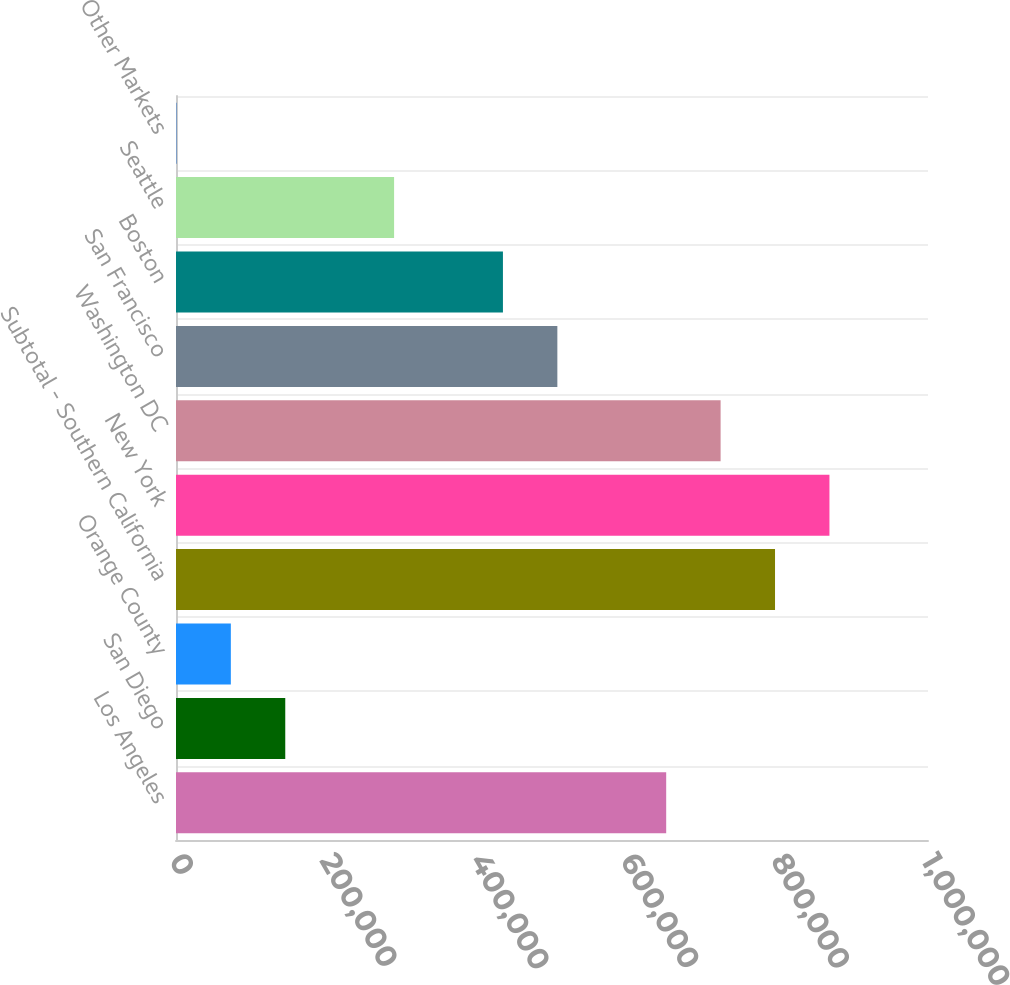Convert chart to OTSL. <chart><loc_0><loc_0><loc_500><loc_500><bar_chart><fcel>Los Angeles<fcel>San Diego<fcel>Orange County<fcel>Subtotal - Southern California<fcel>New York<fcel>Washington DC<fcel>San Francisco<fcel>Boston<fcel>Seattle<fcel>Other Markets<nl><fcel>651846<fcel>145296<fcel>72932.2<fcel>796574<fcel>868938<fcel>724210<fcel>507117<fcel>434753<fcel>290025<fcel>568<nl></chart> 